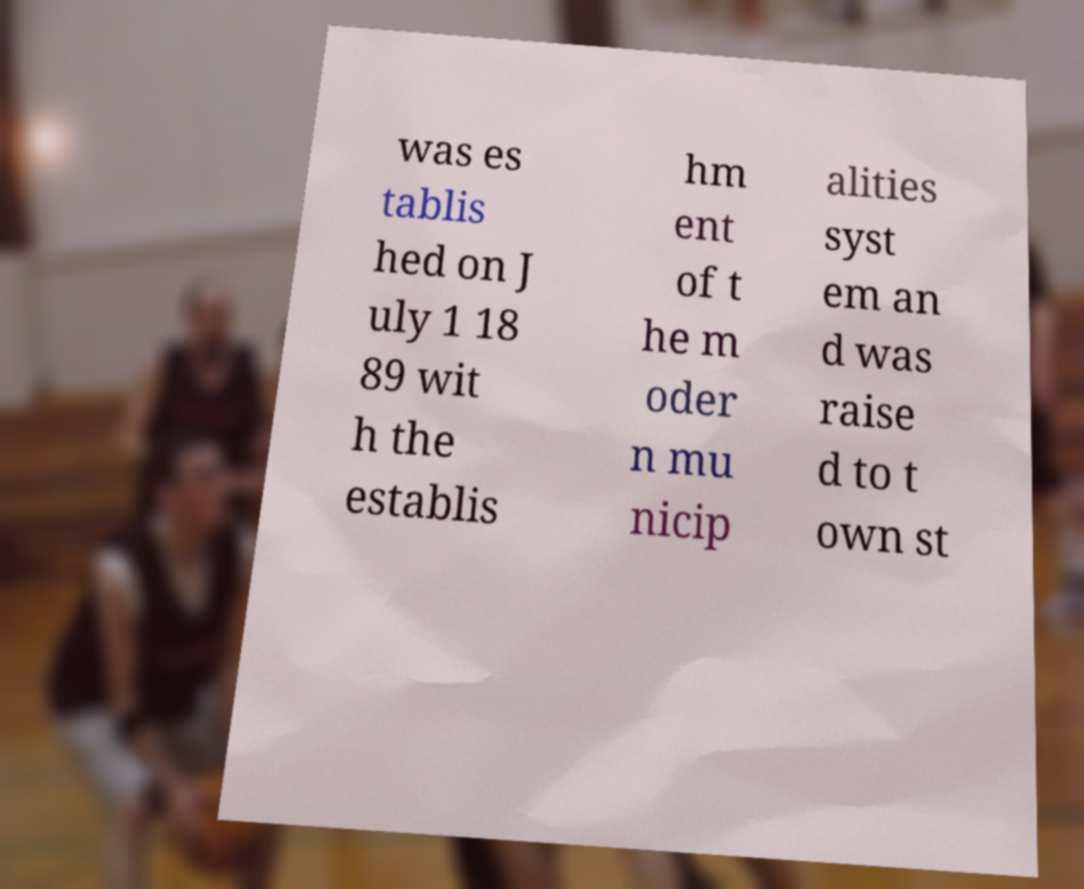Could you assist in decoding the text presented in this image and type it out clearly? was es tablis hed on J uly 1 18 89 wit h the establis hm ent of t he m oder n mu nicip alities syst em an d was raise d to t own st 